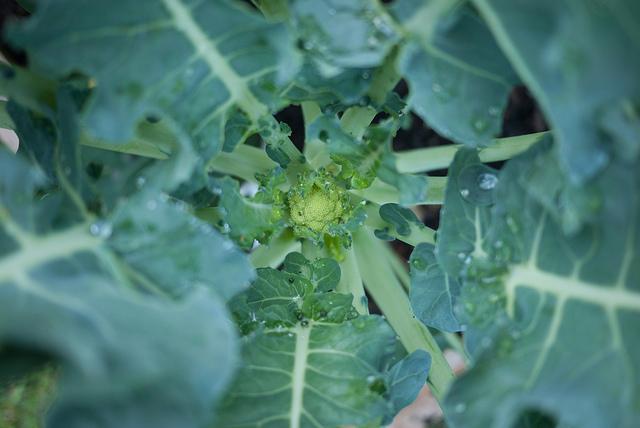Is the plant wet?
Write a very short answer. Yes. Are the greens edible?
Keep it brief. Yes. Is the plant edible?
Short answer required. Yes. Will this plant produce a cruciferous vegetable?
Write a very short answer. Yes. Is that broccoli?
Concise answer only. No. Is it ready to be picked?
Be succinct. No. Is this edible?
Short answer required. Yes. 